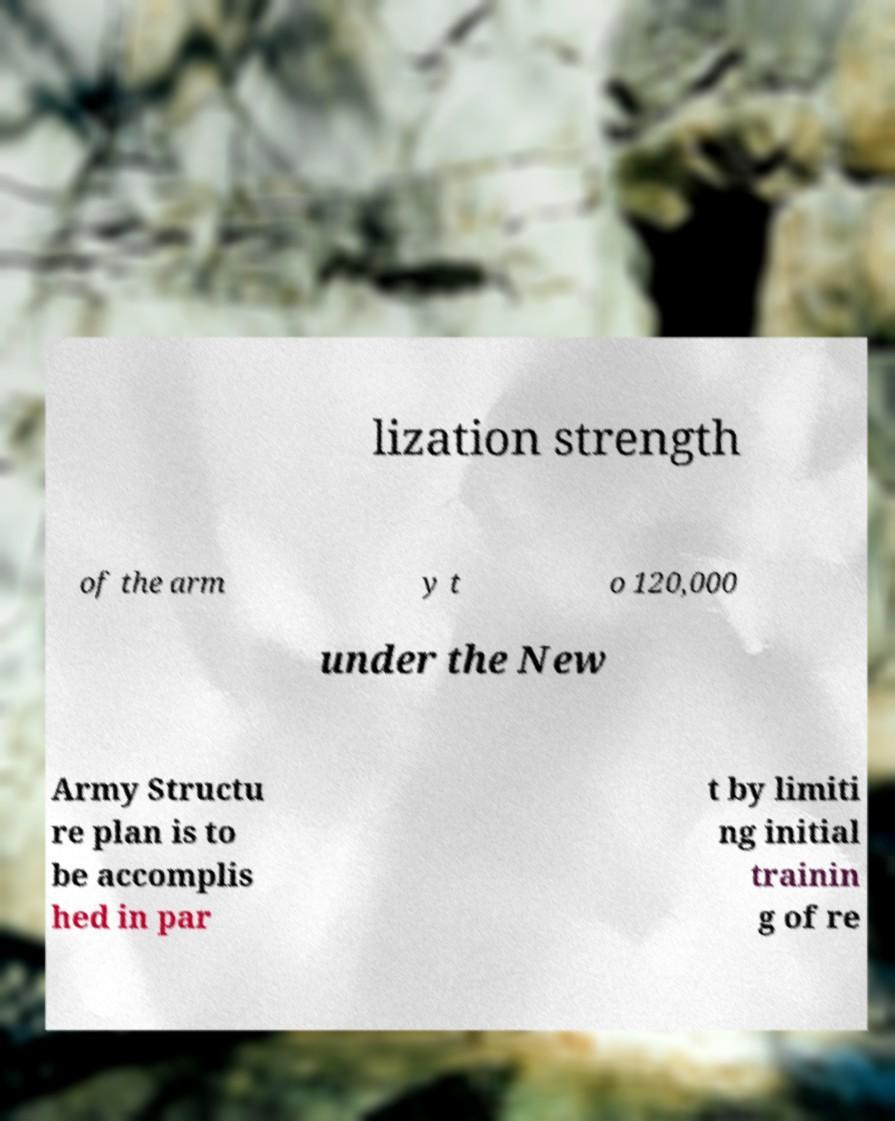Can you accurately transcribe the text from the provided image for me? lization strength of the arm y t o 120,000 under the New Army Structu re plan is to be accomplis hed in par t by limiti ng initial trainin g of re 